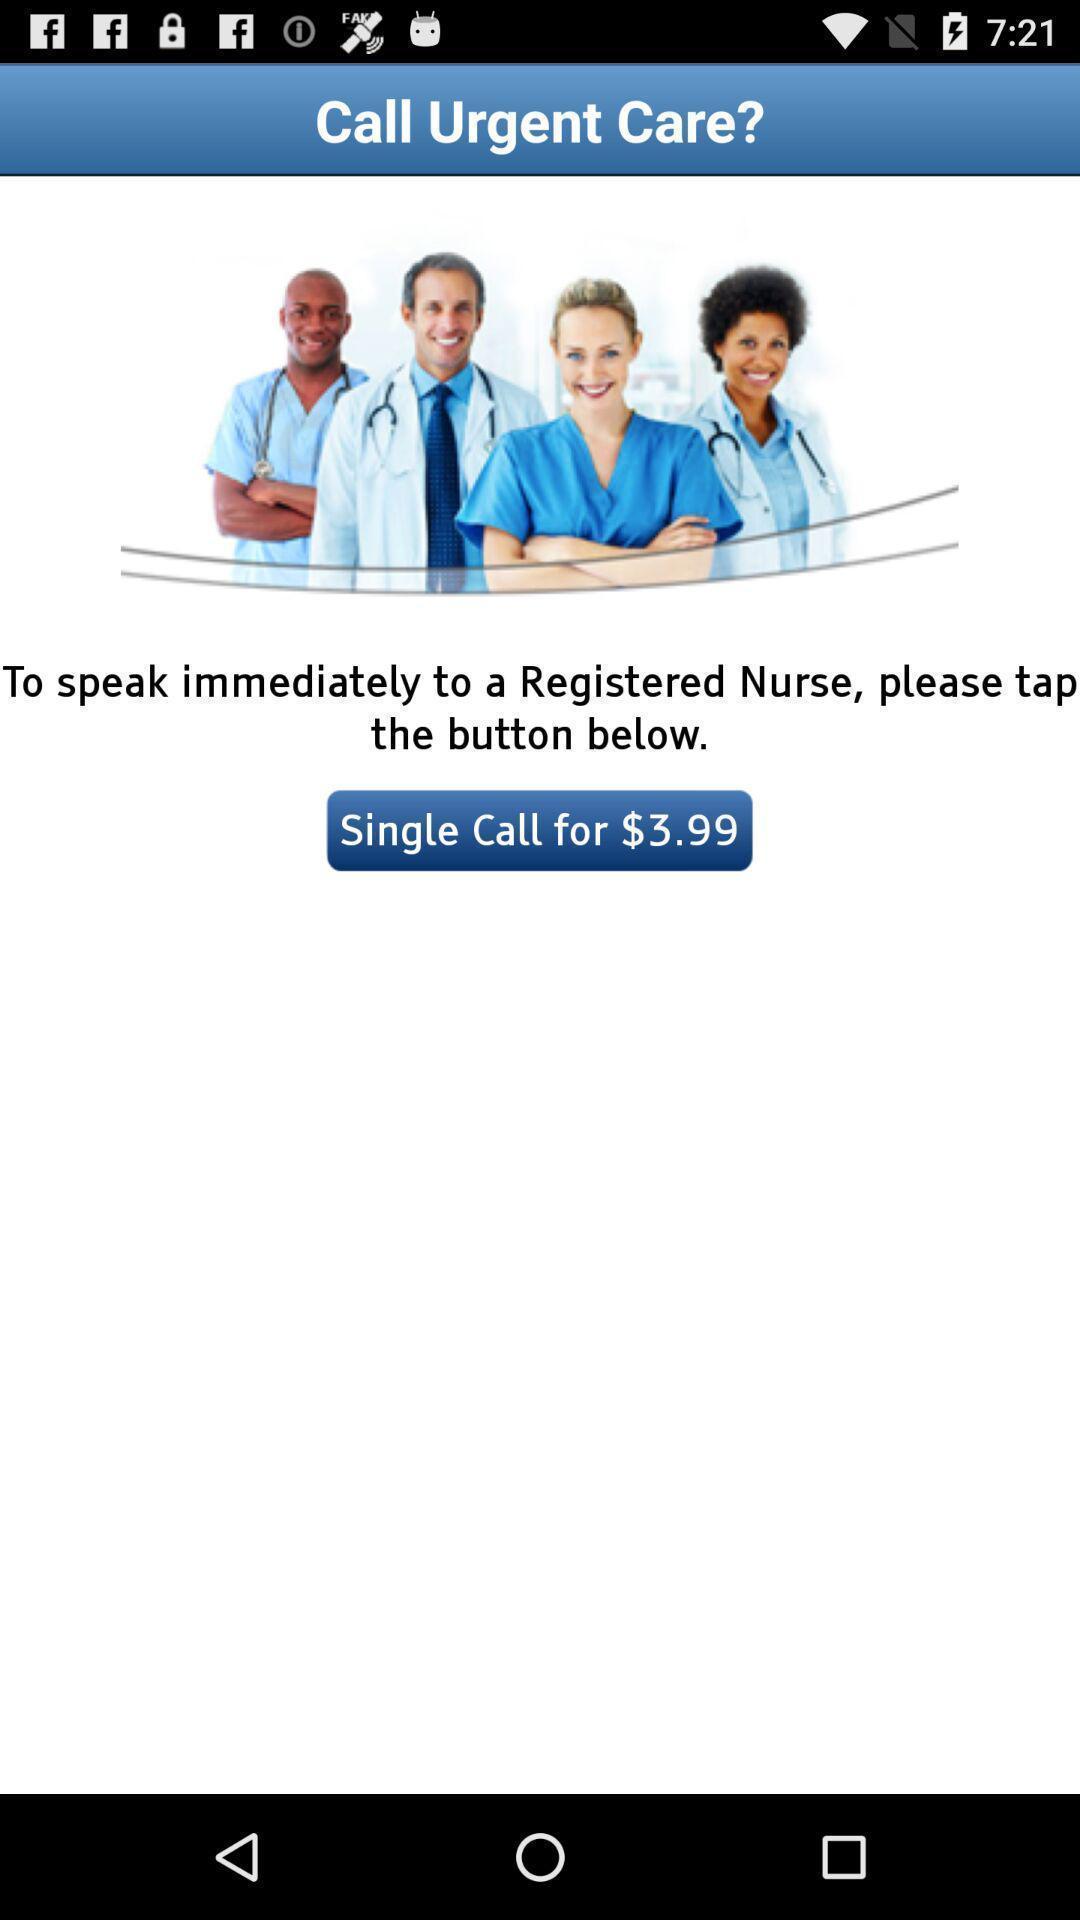Describe the content in this image. Screen showing urgent calling option of a health app. 